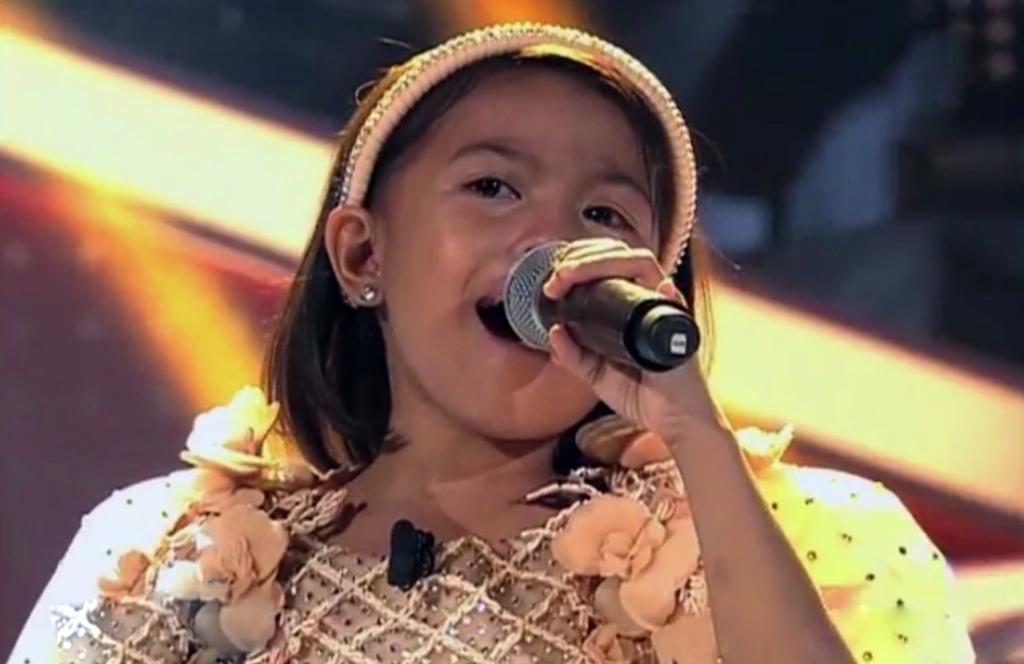Can you describe this image briefly? In this picture we can see a girl holding a mic with her hand and in the background it is blurry. 